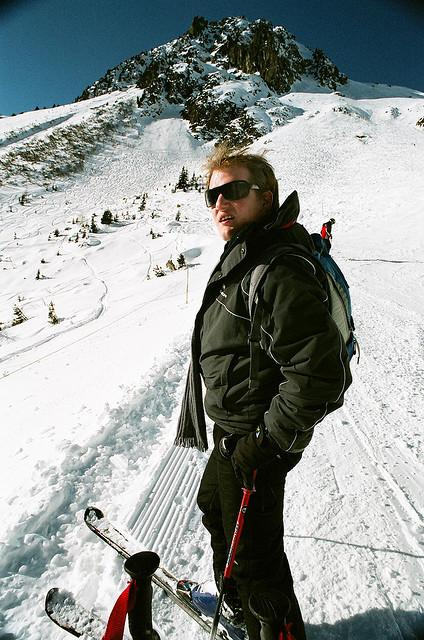What look does the man have on his face? Please explain your reasoning. disgust. A man is looking on with a curled lip and furrowed brow. 